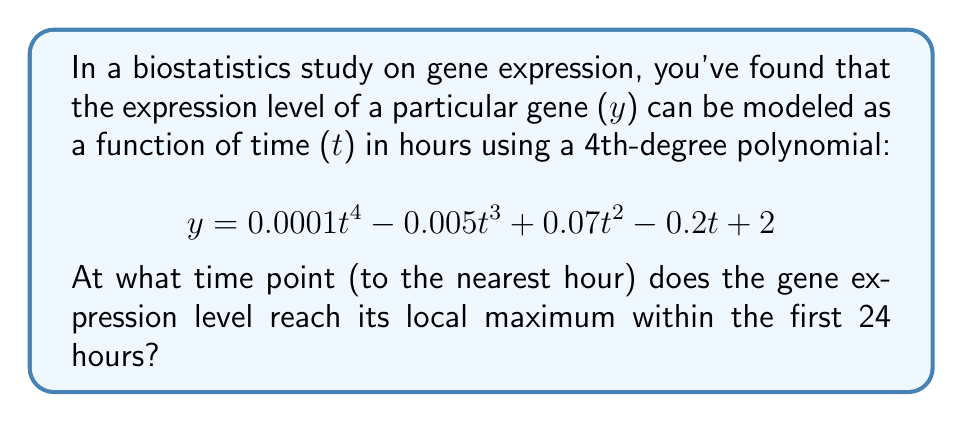Provide a solution to this math problem. To find the local maximum, we need to follow these steps:

1) First, we need to find the derivative of the function:
   $$\frac{dy}{dt} = 0.0004t^3 - 0.015t^2 + 0.14t - 0.2$$

2) To find the critical points, we set the derivative equal to zero:
   $$0.0004t^3 - 0.015t^2 + 0.14t - 0.2 = 0$$

3) This is a cubic equation. While it can be solved analytically, it's more practical to use numerical methods or graphing to find the solutions within our range of interest (0-24 hours).

4) Using a graphing calculator or computational tool, we find that this equation has three real roots:
   $t \approx 1.4$, $t \approx 10.7$, and $t \approx 25.4$

5) Since we're only interested in the first 24 hours, we can disregard the third root.

6) To determine which of these critical points is a local maximum, we can use the second derivative test or simply evaluate the function at these points and the endpoints of our interval.

7) Calculating the y-values:
   At t = 0:  y = 2
   At t ≈ 1.4:  y ≈ 1.8
   At t ≈ 10.7:  y ≈ 3.2
   At t = 24:  y ≈ -25.9

8) We can see that the highest value occurs at t ≈ 10.7 hours.

9) Rounding to the nearest hour gives us 11 hours.
Answer: 11 hours 